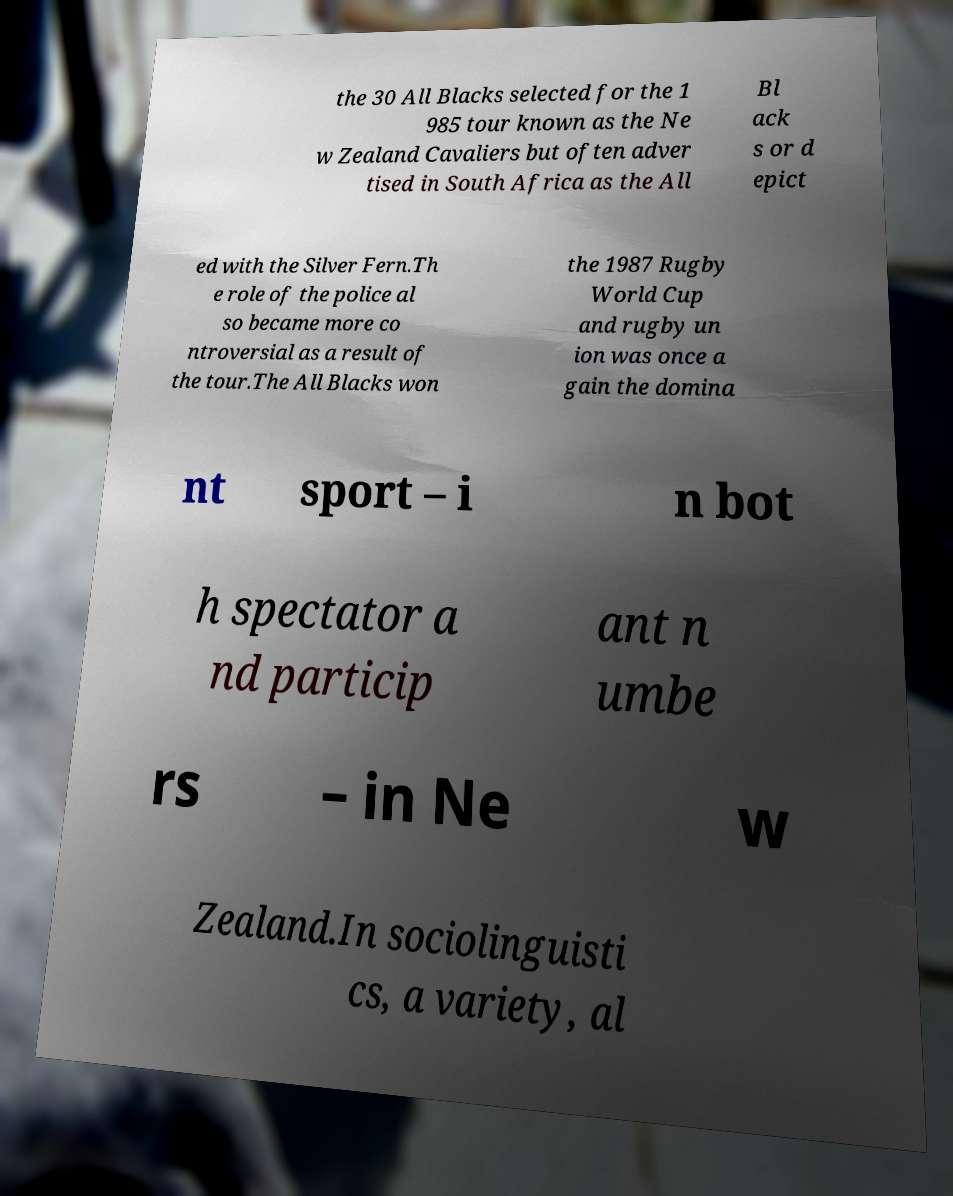I need the written content from this picture converted into text. Can you do that? the 30 All Blacks selected for the 1 985 tour known as the Ne w Zealand Cavaliers but often adver tised in South Africa as the All Bl ack s or d epict ed with the Silver Fern.Th e role of the police al so became more co ntroversial as a result of the tour.The All Blacks won the 1987 Rugby World Cup and rugby un ion was once a gain the domina nt sport – i n bot h spectator a nd particip ant n umbe rs – in Ne w Zealand.In sociolinguisti cs, a variety, al 